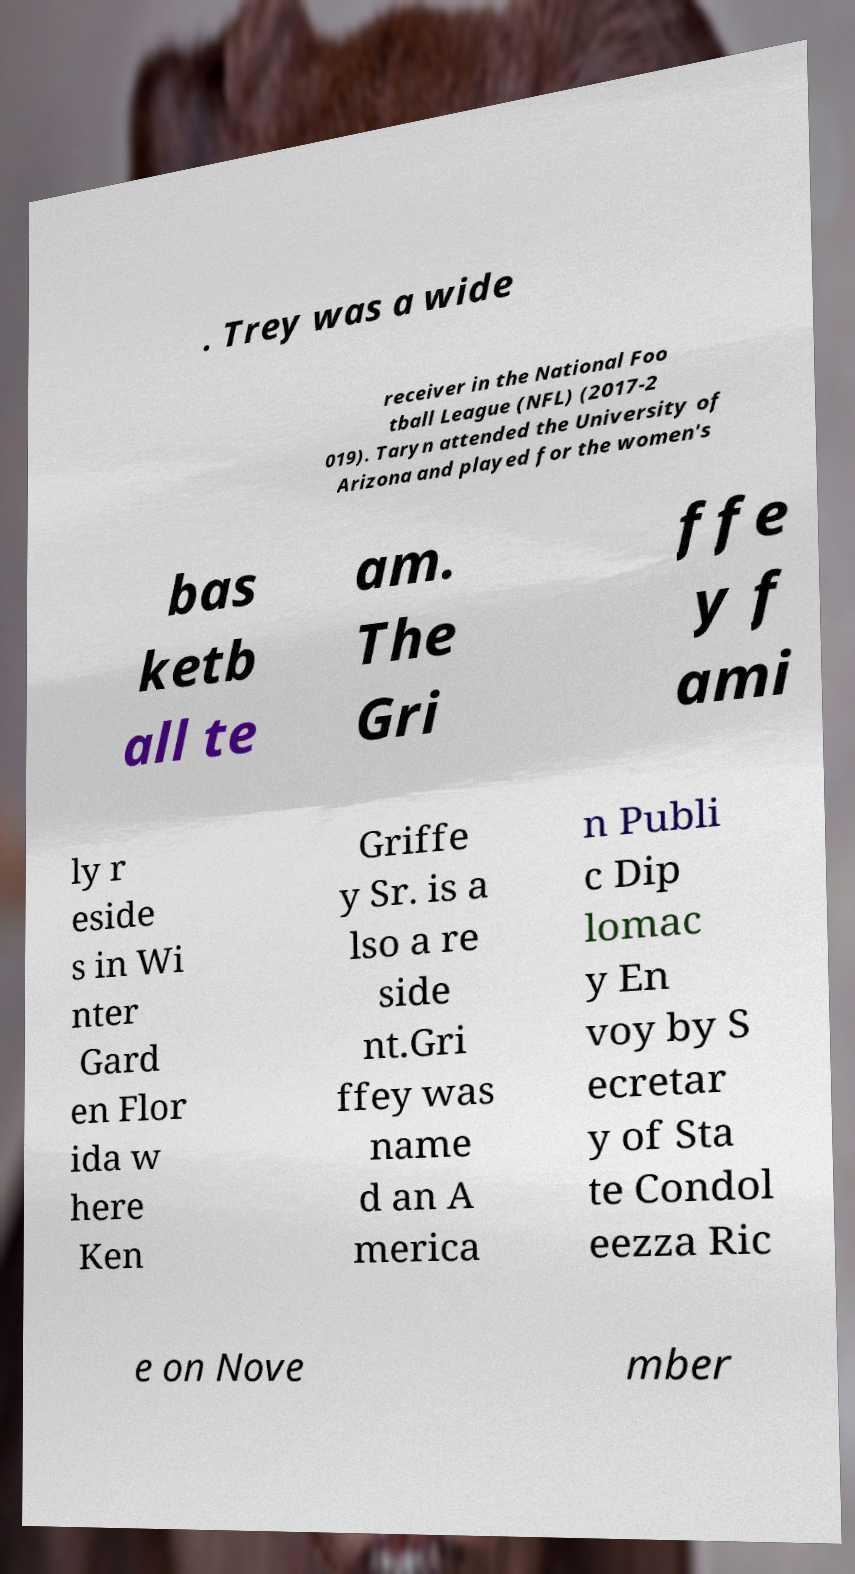What messages or text are displayed in this image? I need them in a readable, typed format. . Trey was a wide receiver in the National Foo tball League (NFL) (2017-2 019). Taryn attended the University of Arizona and played for the women's bas ketb all te am. The Gri ffe y f ami ly r eside s in Wi nter Gard en Flor ida w here Ken Griffe y Sr. is a lso a re side nt.Gri ffey was name d an A merica n Publi c Dip lomac y En voy by S ecretar y of Sta te Condol eezza Ric e on Nove mber 